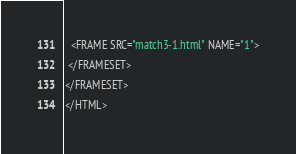Convert code to text. <code><loc_0><loc_0><loc_500><loc_500><_HTML_>  <FRAME SRC="match3-1.html" NAME="1">
 </FRAMESET>
</FRAMESET>
</HTML>
</code> 